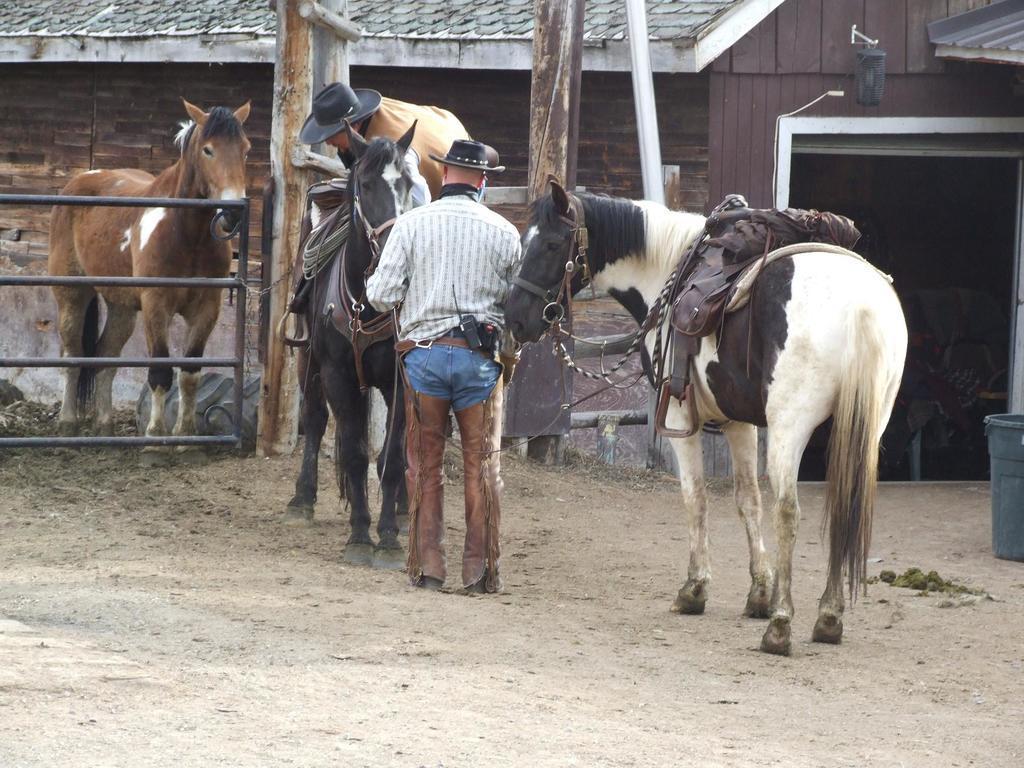How would you summarize this image in a sentence or two? In this image I can see railing, horses, people, shed, poles, bin and things. 